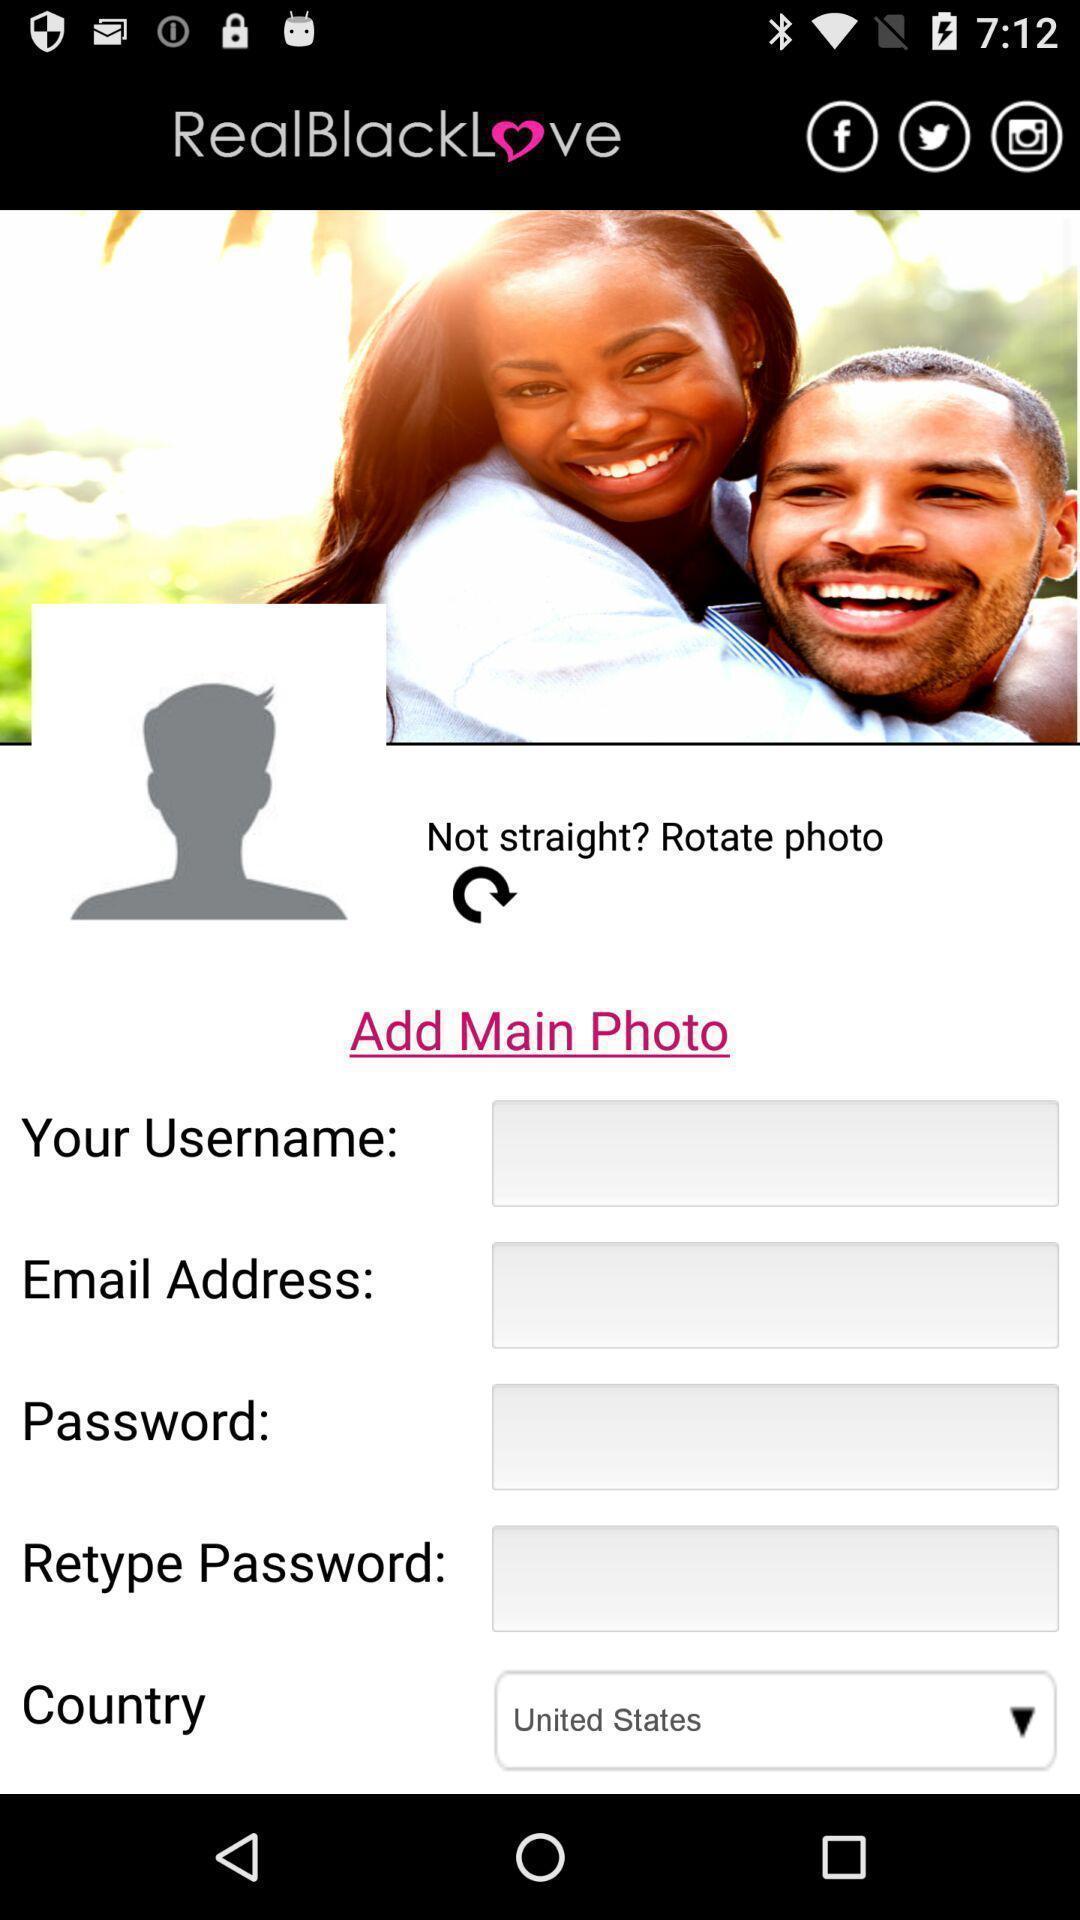Explain the elements present in this screenshot. Screen asking for personal information. 